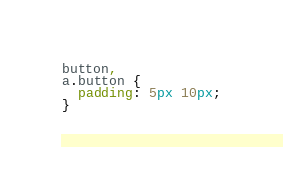<code> <loc_0><loc_0><loc_500><loc_500><_CSS_>button,
a.button {
  padding: 5px 10px;
}
</code> 